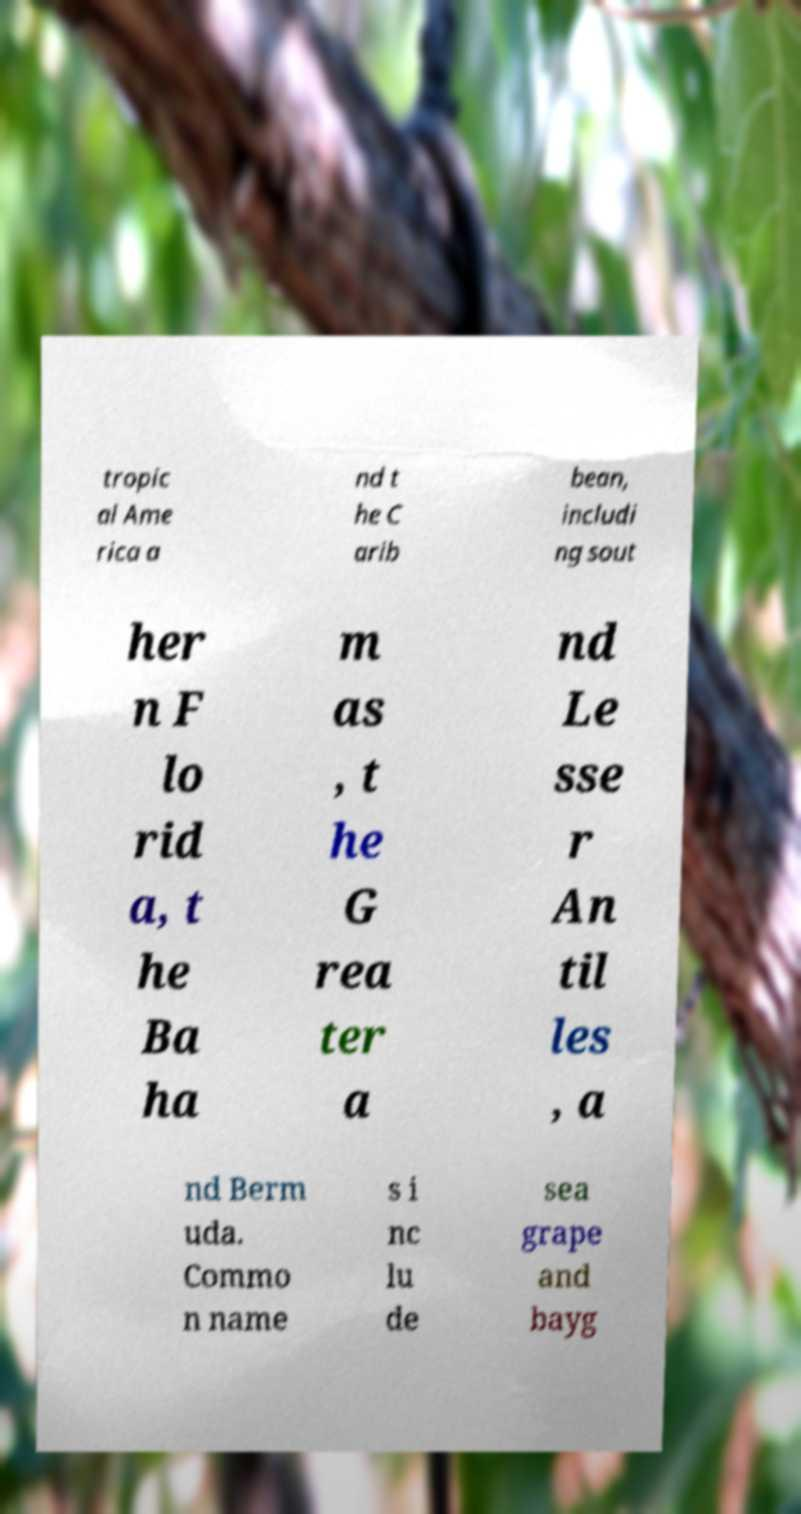Can you accurately transcribe the text from the provided image for me? tropic al Ame rica a nd t he C arib bean, includi ng sout her n F lo rid a, t he Ba ha m as , t he G rea ter a nd Le sse r An til les , a nd Berm uda. Commo n name s i nc lu de sea grape and bayg 